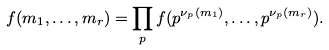<formula> <loc_0><loc_0><loc_500><loc_500>f ( m _ { 1 } , \dots , m _ { r } ) = \prod _ { p } f ( p ^ { \nu _ { p } ( m _ { 1 } ) } , \dots , p ^ { \nu _ { p } ( m _ { r } ) } ) .</formula> 